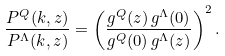Convert formula to latex. <formula><loc_0><loc_0><loc_500><loc_500>\frac { P ^ { Q } ( k , z ) } { P ^ { \Lambda } ( k , z ) } = \left ( \frac { g ^ { Q } ( z ) \, g ^ { \Lambda } ( 0 ) } { g ^ { Q } ( 0 ) \, g ^ { \Lambda } ( z ) } \right ) ^ { 2 } .</formula> 